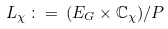Convert formula to latex. <formula><loc_0><loc_0><loc_500><loc_500>L _ { \chi } \, \colon = \, ( E _ { G } \times { \mathbb { C } } _ { \chi } ) / P</formula> 